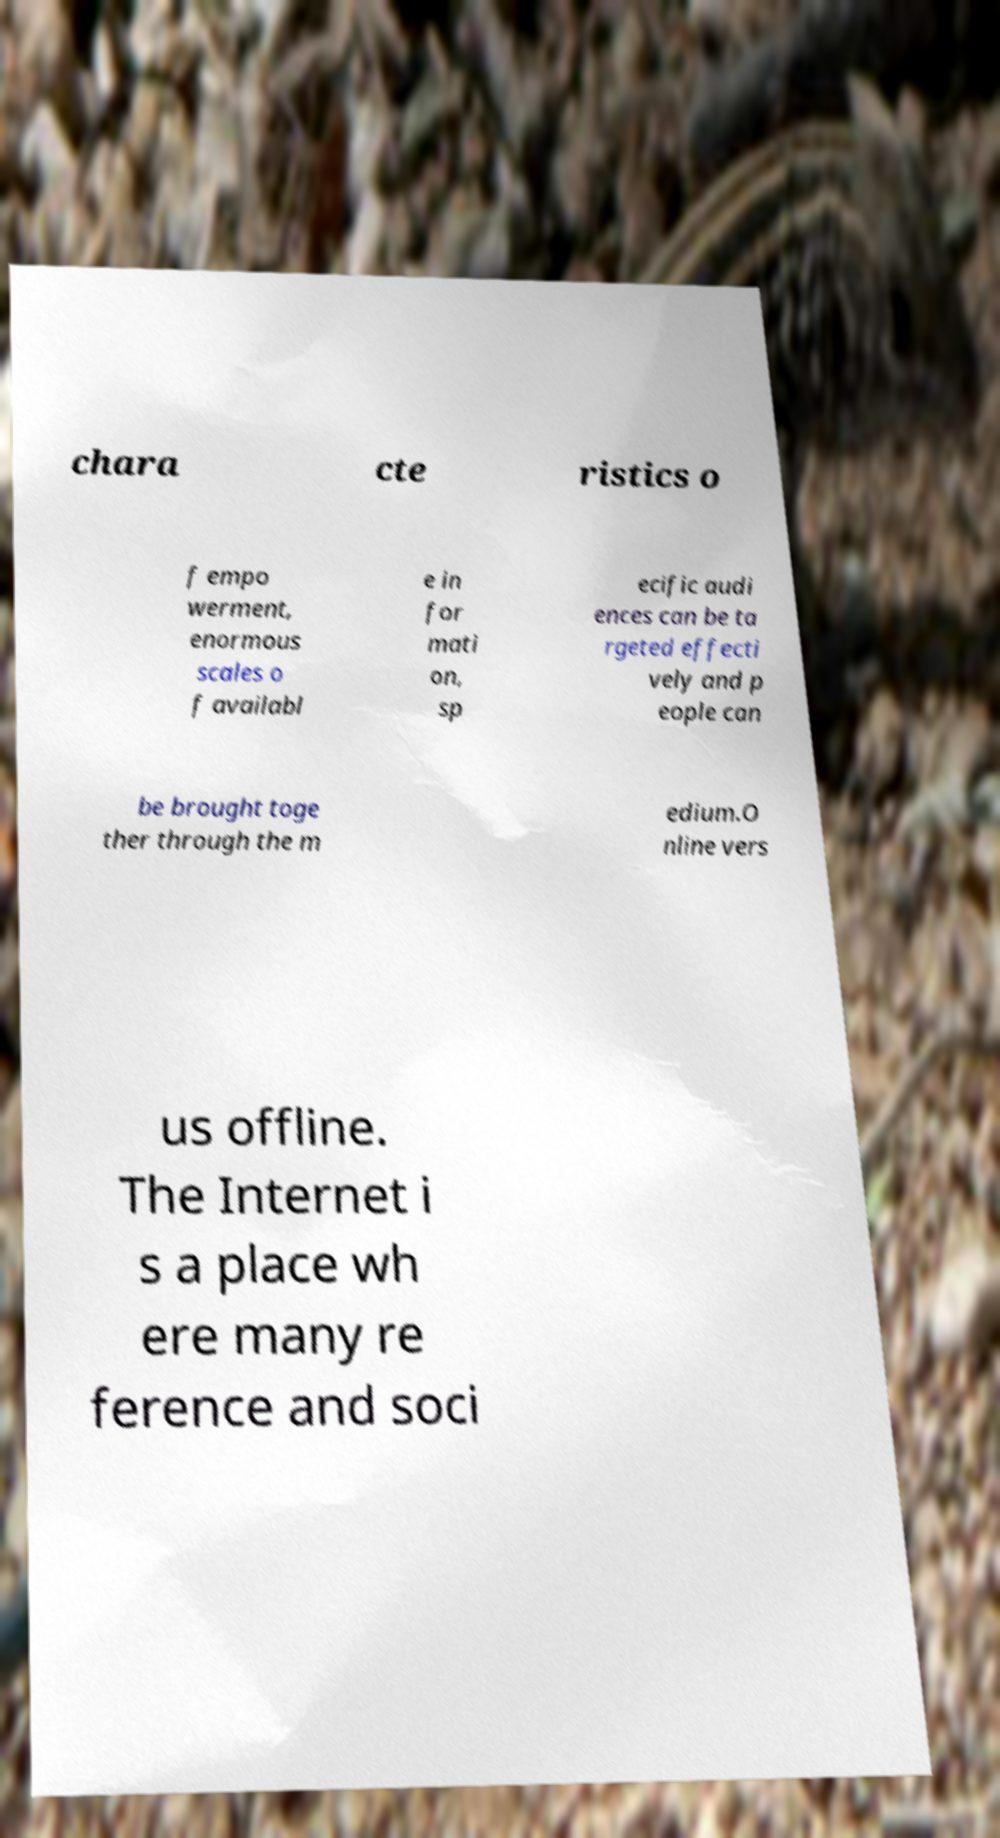I need the written content from this picture converted into text. Can you do that? chara cte ristics o f empo werment, enormous scales o f availabl e in for mati on, sp ecific audi ences can be ta rgeted effecti vely and p eople can be brought toge ther through the m edium.O nline vers us offline. The Internet i s a place wh ere many re ference and soci 